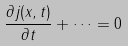<formula> <loc_0><loc_0><loc_500><loc_500>\frac { \partial { j ( x , t ) } } { \partial { t } } + \dots = 0</formula> 